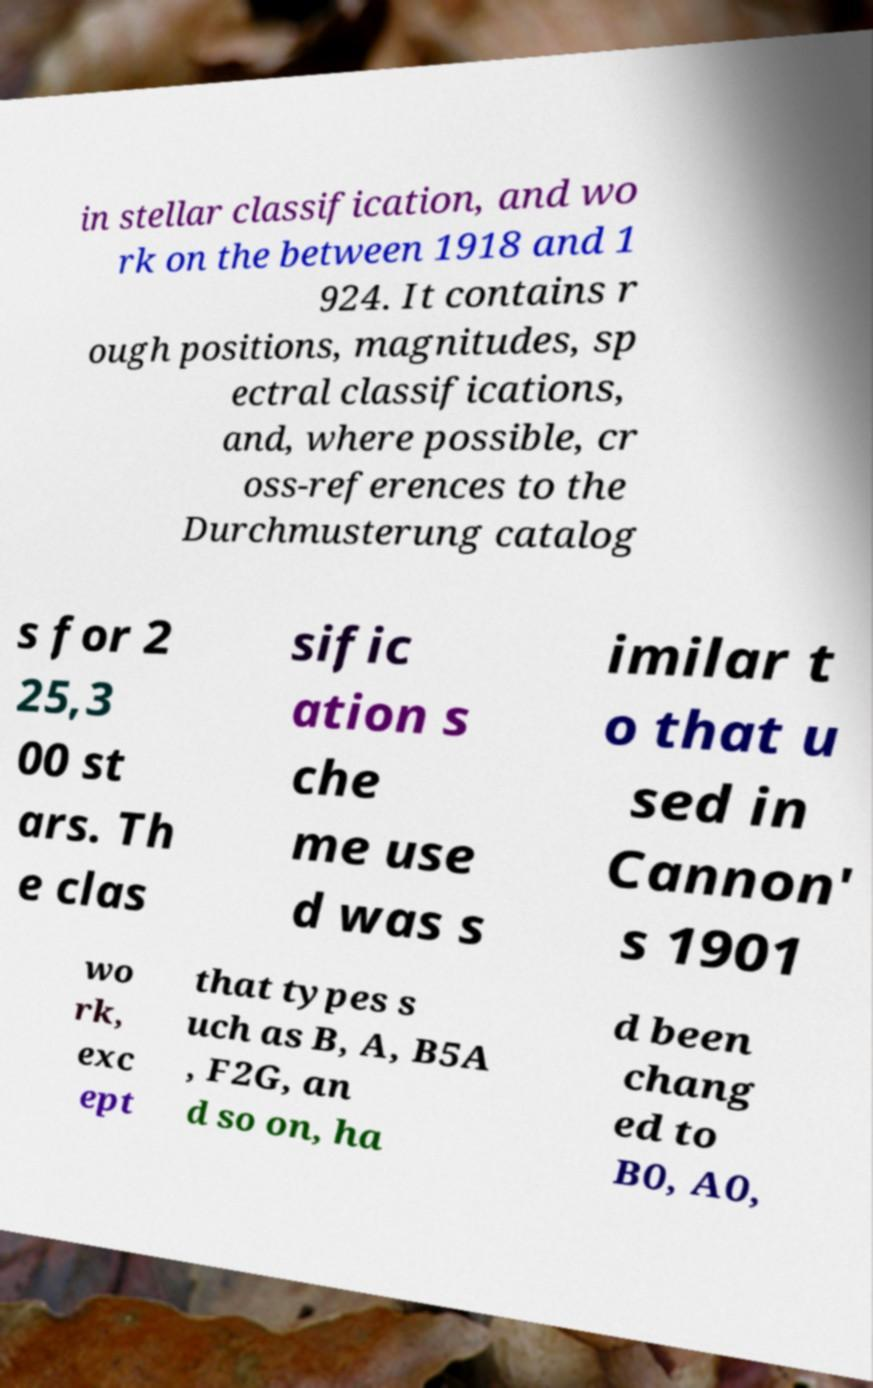For documentation purposes, I need the text within this image transcribed. Could you provide that? in stellar classification, and wo rk on the between 1918 and 1 924. It contains r ough positions, magnitudes, sp ectral classifications, and, where possible, cr oss-references to the Durchmusterung catalog s for 2 25,3 00 st ars. Th e clas sific ation s che me use d was s imilar t o that u sed in Cannon' s 1901 wo rk, exc ept that types s uch as B, A, B5A , F2G, an d so on, ha d been chang ed to B0, A0, 